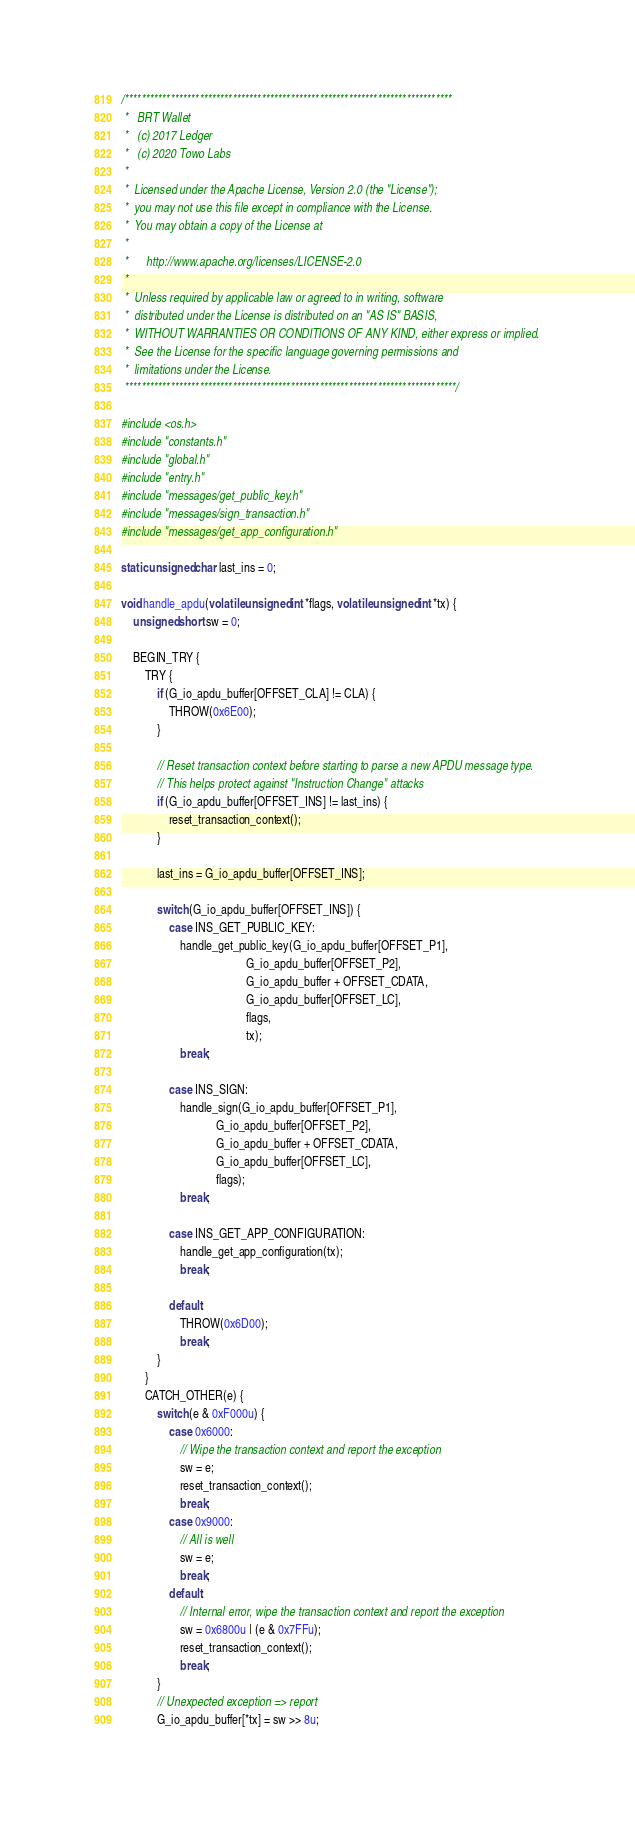<code> <loc_0><loc_0><loc_500><loc_500><_C_>/*******************************************************************************
 *   BRT Wallet
 *   (c) 2017 Ledger
 *   (c) 2020 Towo Labs
 *
 *  Licensed under the Apache License, Version 2.0 (the "License");
 *  you may not use this file except in compliance with the License.
 *  You may obtain a copy of the License at
 *
 *      http://www.apache.org/licenses/LICENSE-2.0
 *
 *  Unless required by applicable law or agreed to in writing, software
 *  distributed under the License is distributed on an "AS IS" BASIS,
 *  WITHOUT WARRANTIES OR CONDITIONS OF ANY KIND, either express or implied.
 *  See the License for the specific language governing permissions and
 *  limitations under the License.
 ********************************************************************************/

#include <os.h>
#include "constants.h"
#include "global.h"
#include "entry.h"
#include "messages/get_public_key.h"
#include "messages/sign_transaction.h"
#include "messages/get_app_configuration.h"

static unsigned char last_ins = 0;

void handle_apdu(volatile unsigned int *flags, volatile unsigned int *tx) {
    unsigned short sw = 0;

    BEGIN_TRY {
        TRY {
            if (G_io_apdu_buffer[OFFSET_CLA] != CLA) {
                THROW(0x6E00);
            }

            // Reset transaction context before starting to parse a new APDU message type.
            // This helps protect against "Instruction Change" attacks
            if (G_io_apdu_buffer[OFFSET_INS] != last_ins) {
                reset_transaction_context();
            }

            last_ins = G_io_apdu_buffer[OFFSET_INS];

            switch (G_io_apdu_buffer[OFFSET_INS]) {
                case INS_GET_PUBLIC_KEY:
                    handle_get_public_key(G_io_apdu_buffer[OFFSET_P1],
                                          G_io_apdu_buffer[OFFSET_P2],
                                          G_io_apdu_buffer + OFFSET_CDATA,
                                          G_io_apdu_buffer[OFFSET_LC],
                                          flags,
                                          tx);
                    break;

                case INS_SIGN:
                    handle_sign(G_io_apdu_buffer[OFFSET_P1],
                                G_io_apdu_buffer[OFFSET_P2],
                                G_io_apdu_buffer + OFFSET_CDATA,
                                G_io_apdu_buffer[OFFSET_LC],
                                flags);
                    break;

                case INS_GET_APP_CONFIGURATION:
                    handle_get_app_configuration(tx);
                    break;

                default:
                    THROW(0x6D00);
                    break;
            }
        }
        CATCH_OTHER(e) {
            switch (e & 0xF000u) {
                case 0x6000:
                    // Wipe the transaction context and report the exception
                    sw = e;
                    reset_transaction_context();
                    break;
                case 0x9000:
                    // All is well
                    sw = e;
                    break;
                default:
                    // Internal error, wipe the transaction context and report the exception
                    sw = 0x6800u | (e & 0x7FFu);
                    reset_transaction_context();
                    break;
            }
            // Unexpected exception => report
            G_io_apdu_buffer[*tx] = sw >> 8u;</code> 